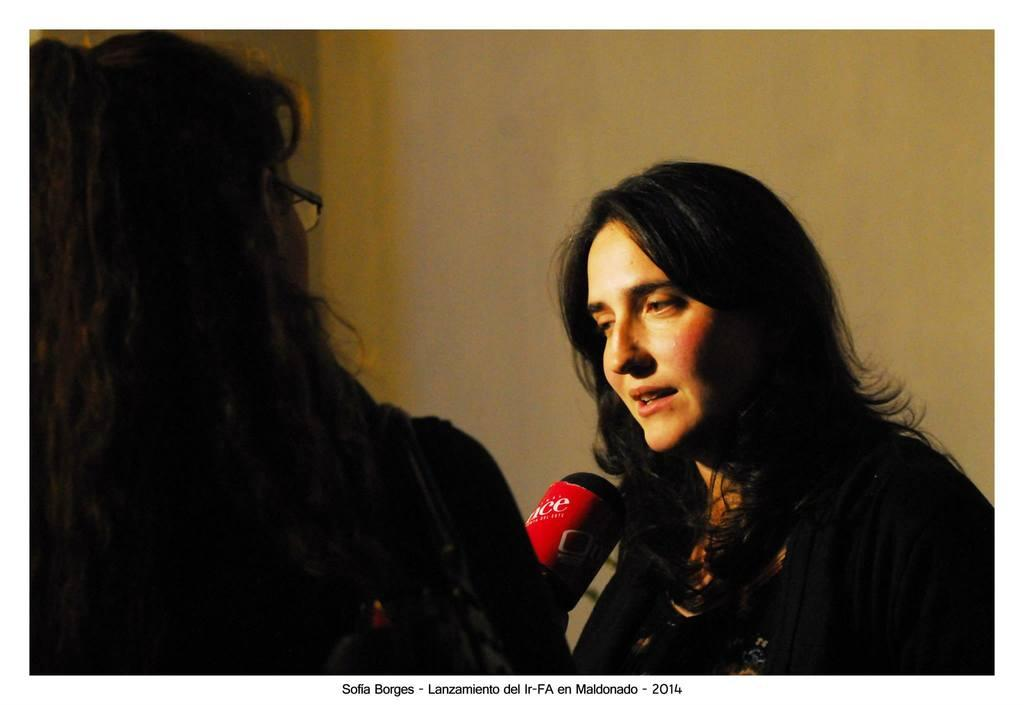How many people are in the image? There are two women in the image. What can be seen in the background of the image? There is a wall in the background of the image. Is there any text or marking at the bottom of the image? Yes, there is a watermark at the bottom of the image. Are there any giants playing a game of match in the image? There are no giants or matches present in the image. 